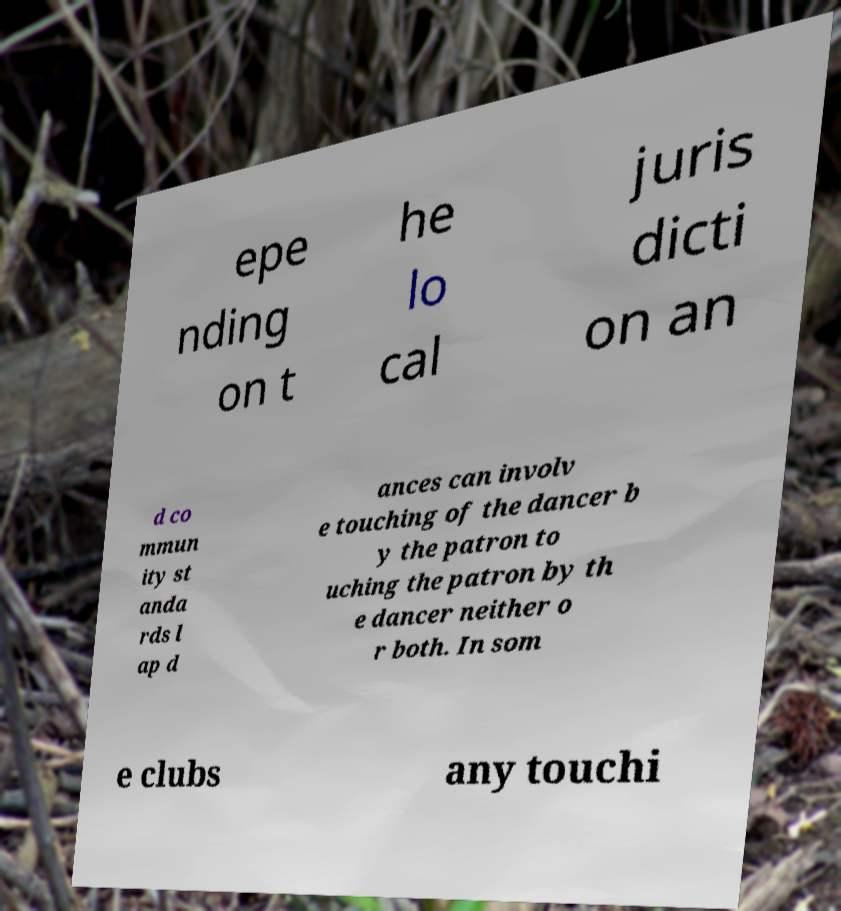There's text embedded in this image that I need extracted. Can you transcribe it verbatim? epe nding on t he lo cal juris dicti on an d co mmun ity st anda rds l ap d ances can involv e touching of the dancer b y the patron to uching the patron by th e dancer neither o r both. In som e clubs any touchi 